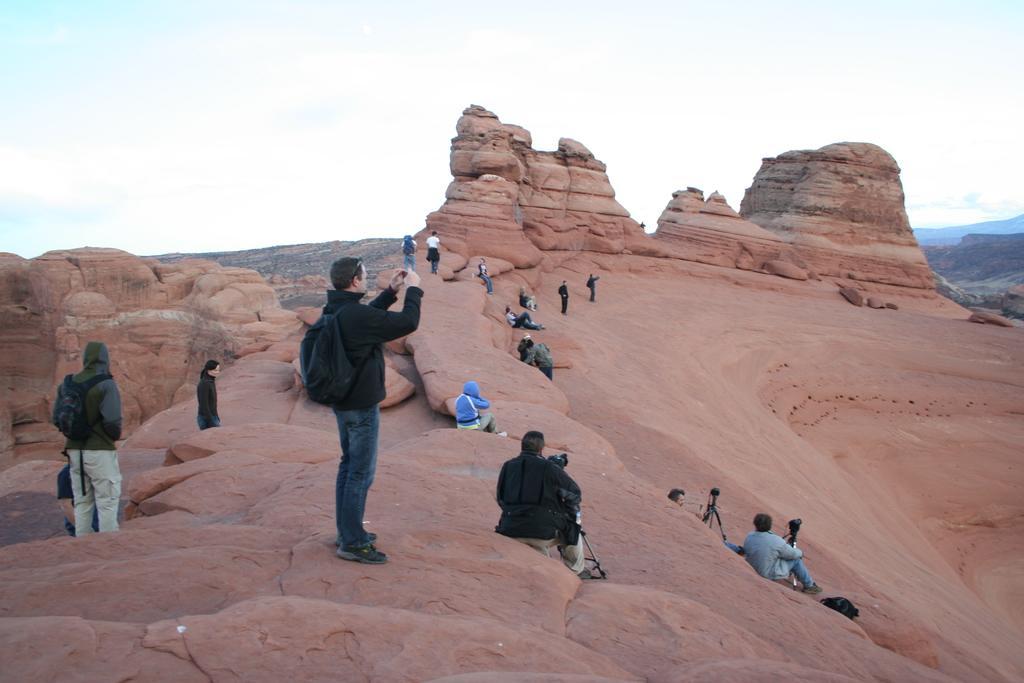Could you give a brief overview of what you see in this image? In this image there are some person sitting as we can see in middle of this image and there is a person standing at middle of this image is holding a mobile and wearing black color dress and black color backpack. There is one another person right side to him is sitting and there is a mountain in middle of this image and back side to this image as well. There is a sky at top of this image. there are some persons at left side of this image and there is one man wearing blue color dress sitting in middle of this image. 